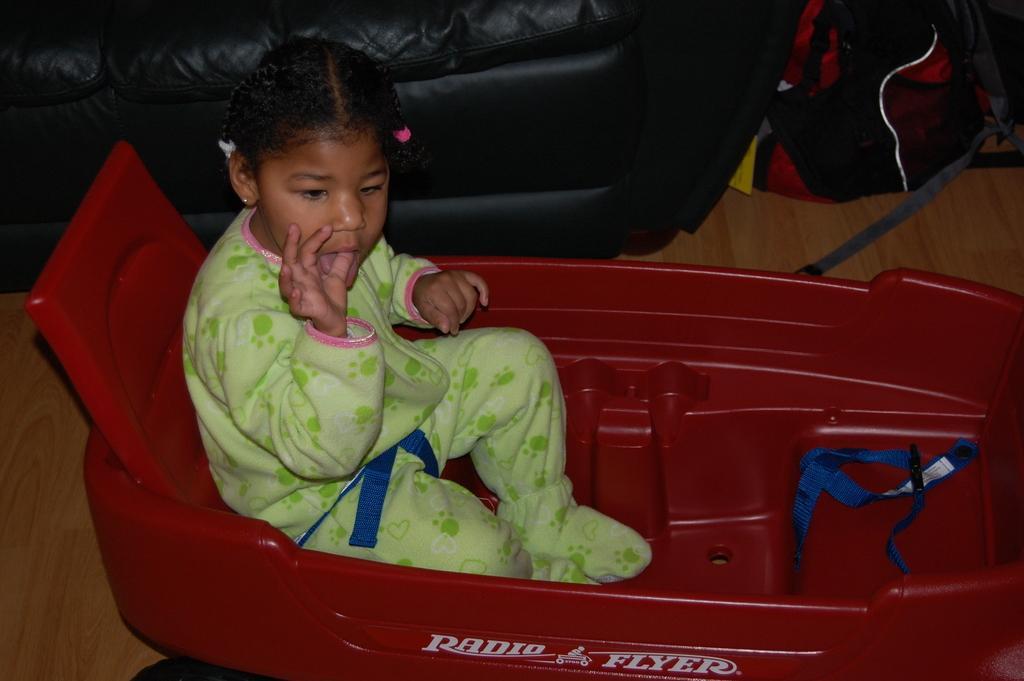Please provide a concise description of this image. In the center of the image, we can see a kid on the grow ride and in the background, there is a sofa and we can see a bag. At the bottom, there is a floor. 